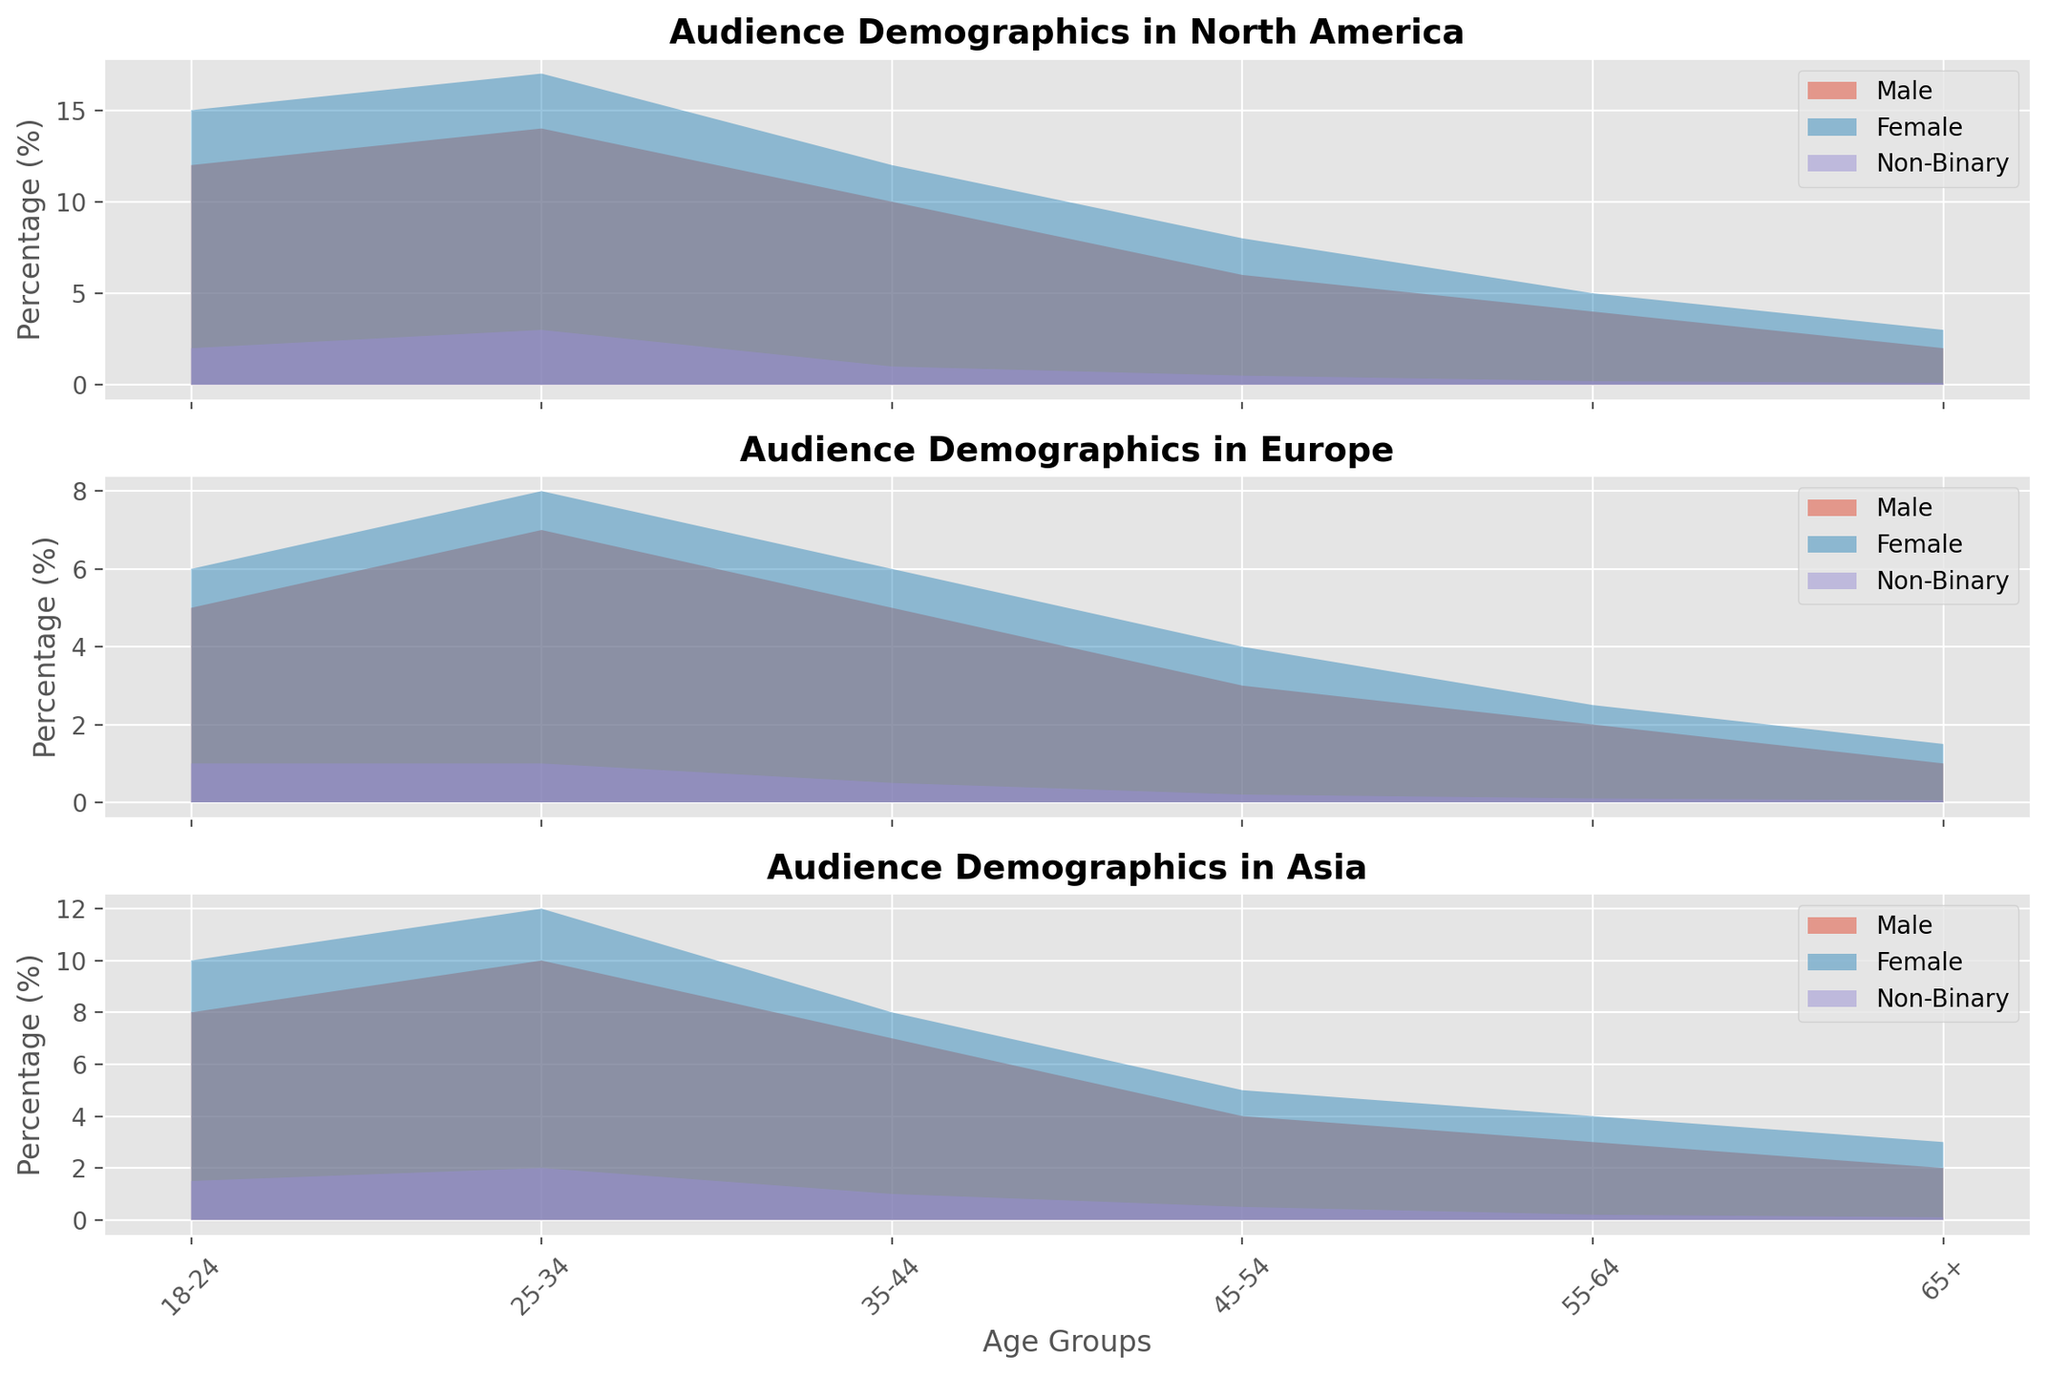Which age group has the highest percentage of female audience in North America? To find this, look at the plot for North America and compare the heights of the areas that represent the female audience across different age groups. The tallest area for females corresponds to the 25-34 age group.
Answer: 25-34 Between North America and Europe, in which region is the percentage of 18-24 non-binary audience higher? Compare the height of the non-binary areas for the 18-24 age group in both the North America and Europe plots. The area in North America is slightly higher compared to Europe.
Answer: North America How does the percentage of the 45-54 male audience in Asia compare to Europe? Check the height of the area representing the 45-54 male audience in both Asia and Europe. The area is higher in Asia, indicating a higher percentage.
Answer: Higher in Asia What is the total percentage of audiences aged 55+ in North America, for all genders combined? Sum the heights of the areas for males, females, and non-binary audiences within the 55-64 and 65+ age groups in North America: 4+5+0.2+2+3+0.1 = 14.3%.
Answer: 14.3% In which region is the female audience aged 25-34 the highest? Compare the heights of the female audience areas aged 25-34 across all regions: North America, Europe, and Asia. The tallest area is in North America.
Answer: North America Among the non-binary audience, which age group has the lowest percentage across all regions? Compare the height of the non-binary areas across all age groups and regions. The lowest area corresponds to the 65+ age group in Europe.
Answer: 65+ in Europe How does the male audience aged 18-24 percentage in Asia compare to North America? Compare the height of the male audience area for the 18-24 age group in Asia and North America. The area representing Asia is smaller, indicating a lower percentage.
Answer: Lower in Asia What's the difference in percentage between female audiences aged 35-44 and 45-54 in Europe? Subtract the percentage of the 45-54 female audience in Europe from the percentage of the 35-44 female audience in Europe: 6 - 4 = 2%.
Answer: 2% What's the average percentage of the female audience across all age groups in Asia? Sum the percentages for all age groups for females in Asia and divide by the number of age groups: (10+12+8+5+4+3)/6 = 7%.
Answer: 7% Which gender has the largest percentage drop from 18-24 to 25-34 age group in North America? Subtract the percentage of the 25-34 age group from the 18-24 age group for each gender in North America and compare the values. Males drop from 12 to 14 which is an increase, hence non-binary with drop from 2 to 3 being also an increase, and females drop from 15 to 17 which is an increase as well, all genders show increase and hence non binary remains with least increase.
Answer: non-binary 